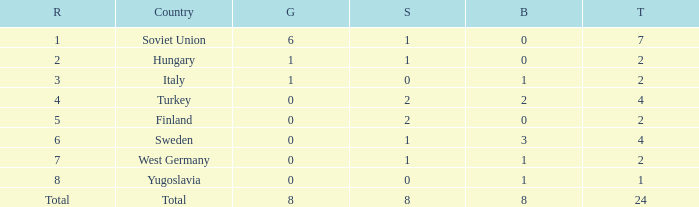Give me the full table as a dictionary. {'header': ['R', 'Country', 'G', 'S', 'B', 'T'], 'rows': [['1', 'Soviet Union', '6', '1', '0', '7'], ['2', 'Hungary', '1', '1', '0', '2'], ['3', 'Italy', '1', '0', '1', '2'], ['4', 'Turkey', '0', '2', '2', '4'], ['5', 'Finland', '0', '2', '0', '2'], ['6', 'Sweden', '0', '1', '3', '4'], ['7', 'West Germany', '0', '1', '1', '2'], ['8', 'Yugoslavia', '0', '0', '1', '1'], ['Total', 'Total', '8', '8', '8', '24']]} What is the lowest Bronze, when Gold is less than 0? None. 